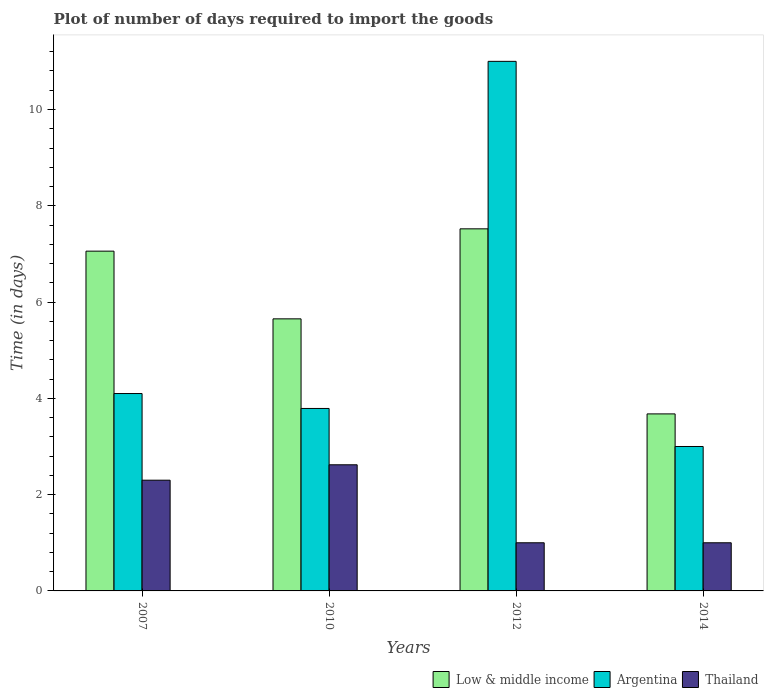How many different coloured bars are there?
Make the answer very short. 3. How many groups of bars are there?
Offer a terse response. 4. Are the number of bars per tick equal to the number of legend labels?
Give a very brief answer. Yes. How many bars are there on the 4th tick from the left?
Your response must be concise. 3. What is the label of the 4th group of bars from the left?
Offer a very short reply. 2014. In how many cases, is the number of bars for a given year not equal to the number of legend labels?
Make the answer very short. 0. What is the time required to import goods in Low & middle income in 2007?
Provide a short and direct response. 7.06. Across all years, what is the maximum time required to import goods in Argentina?
Your answer should be compact. 11. Across all years, what is the minimum time required to import goods in Low & middle income?
Offer a terse response. 3.68. What is the total time required to import goods in Low & middle income in the graph?
Offer a terse response. 23.91. What is the difference between the time required to import goods in Argentina in 2010 and that in 2014?
Provide a short and direct response. 0.79. What is the difference between the time required to import goods in Argentina in 2014 and the time required to import goods in Thailand in 2012?
Your response must be concise. 2. What is the average time required to import goods in Low & middle income per year?
Offer a very short reply. 5.98. In the year 2010, what is the difference between the time required to import goods in Thailand and time required to import goods in Low & middle income?
Offer a terse response. -3.03. In how many years, is the time required to import goods in Thailand greater than 4.4 days?
Offer a very short reply. 0. What is the ratio of the time required to import goods in Low & middle income in 2007 to that in 2014?
Offer a very short reply. 1.92. Is the time required to import goods in Thailand in 2012 less than that in 2014?
Your response must be concise. No. What is the difference between the highest and the second highest time required to import goods in Thailand?
Offer a terse response. 0.32. What is the difference between the highest and the lowest time required to import goods in Thailand?
Make the answer very short. 1.62. Is the sum of the time required to import goods in Argentina in 2010 and 2014 greater than the maximum time required to import goods in Thailand across all years?
Your answer should be very brief. Yes. What does the 3rd bar from the left in 2014 represents?
Your answer should be very brief. Thailand. How many bars are there?
Offer a terse response. 12. Are all the bars in the graph horizontal?
Provide a short and direct response. No. What is the difference between two consecutive major ticks on the Y-axis?
Ensure brevity in your answer.  2. Does the graph contain grids?
Offer a terse response. No. How many legend labels are there?
Make the answer very short. 3. What is the title of the graph?
Provide a succinct answer. Plot of number of days required to import the goods. Does "Australia" appear as one of the legend labels in the graph?
Your answer should be compact. No. What is the label or title of the X-axis?
Ensure brevity in your answer.  Years. What is the label or title of the Y-axis?
Offer a terse response. Time (in days). What is the Time (in days) in Low & middle income in 2007?
Offer a terse response. 7.06. What is the Time (in days) of Argentina in 2007?
Your answer should be compact. 4.1. What is the Time (in days) of Thailand in 2007?
Make the answer very short. 2.3. What is the Time (in days) in Low & middle income in 2010?
Ensure brevity in your answer.  5.65. What is the Time (in days) in Argentina in 2010?
Your response must be concise. 3.79. What is the Time (in days) in Thailand in 2010?
Provide a succinct answer. 2.62. What is the Time (in days) in Low & middle income in 2012?
Your answer should be compact. 7.52. What is the Time (in days) of Argentina in 2012?
Make the answer very short. 11. What is the Time (in days) of Thailand in 2012?
Offer a very short reply. 1. What is the Time (in days) in Low & middle income in 2014?
Offer a very short reply. 3.68. What is the Time (in days) in Argentina in 2014?
Make the answer very short. 3. What is the Time (in days) in Thailand in 2014?
Ensure brevity in your answer.  1. Across all years, what is the maximum Time (in days) of Low & middle income?
Your answer should be very brief. 7.52. Across all years, what is the maximum Time (in days) in Thailand?
Your answer should be very brief. 2.62. Across all years, what is the minimum Time (in days) of Low & middle income?
Offer a terse response. 3.68. Across all years, what is the minimum Time (in days) in Thailand?
Your answer should be compact. 1. What is the total Time (in days) in Low & middle income in the graph?
Your response must be concise. 23.91. What is the total Time (in days) of Argentina in the graph?
Ensure brevity in your answer.  21.89. What is the total Time (in days) in Thailand in the graph?
Give a very brief answer. 6.92. What is the difference between the Time (in days) in Low & middle income in 2007 and that in 2010?
Give a very brief answer. 1.41. What is the difference between the Time (in days) in Argentina in 2007 and that in 2010?
Provide a succinct answer. 0.31. What is the difference between the Time (in days) of Thailand in 2007 and that in 2010?
Ensure brevity in your answer.  -0.32. What is the difference between the Time (in days) in Low & middle income in 2007 and that in 2012?
Ensure brevity in your answer.  -0.46. What is the difference between the Time (in days) of Thailand in 2007 and that in 2012?
Your response must be concise. 1.3. What is the difference between the Time (in days) of Low & middle income in 2007 and that in 2014?
Provide a succinct answer. 3.38. What is the difference between the Time (in days) in Argentina in 2007 and that in 2014?
Ensure brevity in your answer.  1.1. What is the difference between the Time (in days) in Thailand in 2007 and that in 2014?
Your response must be concise. 1.3. What is the difference between the Time (in days) in Low & middle income in 2010 and that in 2012?
Ensure brevity in your answer.  -1.87. What is the difference between the Time (in days) in Argentina in 2010 and that in 2012?
Keep it short and to the point. -7.21. What is the difference between the Time (in days) of Thailand in 2010 and that in 2012?
Ensure brevity in your answer.  1.62. What is the difference between the Time (in days) of Low & middle income in 2010 and that in 2014?
Provide a succinct answer. 1.97. What is the difference between the Time (in days) of Argentina in 2010 and that in 2014?
Ensure brevity in your answer.  0.79. What is the difference between the Time (in days) of Thailand in 2010 and that in 2014?
Provide a succinct answer. 1.62. What is the difference between the Time (in days) in Low & middle income in 2012 and that in 2014?
Offer a terse response. 3.84. What is the difference between the Time (in days) of Low & middle income in 2007 and the Time (in days) of Argentina in 2010?
Offer a very short reply. 3.27. What is the difference between the Time (in days) of Low & middle income in 2007 and the Time (in days) of Thailand in 2010?
Make the answer very short. 4.44. What is the difference between the Time (in days) of Argentina in 2007 and the Time (in days) of Thailand in 2010?
Your response must be concise. 1.48. What is the difference between the Time (in days) of Low & middle income in 2007 and the Time (in days) of Argentina in 2012?
Offer a very short reply. -3.94. What is the difference between the Time (in days) of Low & middle income in 2007 and the Time (in days) of Thailand in 2012?
Your answer should be very brief. 6.06. What is the difference between the Time (in days) of Low & middle income in 2007 and the Time (in days) of Argentina in 2014?
Offer a terse response. 4.06. What is the difference between the Time (in days) of Low & middle income in 2007 and the Time (in days) of Thailand in 2014?
Offer a very short reply. 6.06. What is the difference between the Time (in days) of Low & middle income in 2010 and the Time (in days) of Argentina in 2012?
Keep it short and to the point. -5.35. What is the difference between the Time (in days) in Low & middle income in 2010 and the Time (in days) in Thailand in 2012?
Keep it short and to the point. 4.65. What is the difference between the Time (in days) in Argentina in 2010 and the Time (in days) in Thailand in 2012?
Give a very brief answer. 2.79. What is the difference between the Time (in days) of Low & middle income in 2010 and the Time (in days) of Argentina in 2014?
Your response must be concise. 2.65. What is the difference between the Time (in days) in Low & middle income in 2010 and the Time (in days) in Thailand in 2014?
Offer a very short reply. 4.65. What is the difference between the Time (in days) of Argentina in 2010 and the Time (in days) of Thailand in 2014?
Make the answer very short. 2.79. What is the difference between the Time (in days) of Low & middle income in 2012 and the Time (in days) of Argentina in 2014?
Give a very brief answer. 4.52. What is the difference between the Time (in days) of Low & middle income in 2012 and the Time (in days) of Thailand in 2014?
Your answer should be compact. 6.52. What is the average Time (in days) in Low & middle income per year?
Keep it short and to the point. 5.98. What is the average Time (in days) in Argentina per year?
Offer a very short reply. 5.47. What is the average Time (in days) in Thailand per year?
Make the answer very short. 1.73. In the year 2007, what is the difference between the Time (in days) of Low & middle income and Time (in days) of Argentina?
Ensure brevity in your answer.  2.96. In the year 2007, what is the difference between the Time (in days) of Low & middle income and Time (in days) of Thailand?
Make the answer very short. 4.76. In the year 2007, what is the difference between the Time (in days) of Argentina and Time (in days) of Thailand?
Offer a terse response. 1.8. In the year 2010, what is the difference between the Time (in days) in Low & middle income and Time (in days) in Argentina?
Provide a short and direct response. 1.86. In the year 2010, what is the difference between the Time (in days) in Low & middle income and Time (in days) in Thailand?
Give a very brief answer. 3.03. In the year 2010, what is the difference between the Time (in days) in Argentina and Time (in days) in Thailand?
Make the answer very short. 1.17. In the year 2012, what is the difference between the Time (in days) in Low & middle income and Time (in days) in Argentina?
Your response must be concise. -3.48. In the year 2012, what is the difference between the Time (in days) in Low & middle income and Time (in days) in Thailand?
Your answer should be compact. 6.52. In the year 2012, what is the difference between the Time (in days) in Argentina and Time (in days) in Thailand?
Give a very brief answer. 10. In the year 2014, what is the difference between the Time (in days) of Low & middle income and Time (in days) of Argentina?
Keep it short and to the point. 0.68. In the year 2014, what is the difference between the Time (in days) in Low & middle income and Time (in days) in Thailand?
Give a very brief answer. 2.68. In the year 2014, what is the difference between the Time (in days) in Argentina and Time (in days) in Thailand?
Provide a succinct answer. 2. What is the ratio of the Time (in days) of Low & middle income in 2007 to that in 2010?
Your answer should be compact. 1.25. What is the ratio of the Time (in days) of Argentina in 2007 to that in 2010?
Offer a terse response. 1.08. What is the ratio of the Time (in days) of Thailand in 2007 to that in 2010?
Offer a terse response. 0.88. What is the ratio of the Time (in days) of Low & middle income in 2007 to that in 2012?
Offer a very short reply. 0.94. What is the ratio of the Time (in days) in Argentina in 2007 to that in 2012?
Ensure brevity in your answer.  0.37. What is the ratio of the Time (in days) of Thailand in 2007 to that in 2012?
Provide a short and direct response. 2.3. What is the ratio of the Time (in days) of Low & middle income in 2007 to that in 2014?
Keep it short and to the point. 1.92. What is the ratio of the Time (in days) of Argentina in 2007 to that in 2014?
Give a very brief answer. 1.37. What is the ratio of the Time (in days) in Low & middle income in 2010 to that in 2012?
Your answer should be very brief. 0.75. What is the ratio of the Time (in days) in Argentina in 2010 to that in 2012?
Your answer should be compact. 0.34. What is the ratio of the Time (in days) of Thailand in 2010 to that in 2012?
Offer a terse response. 2.62. What is the ratio of the Time (in days) in Low & middle income in 2010 to that in 2014?
Offer a terse response. 1.54. What is the ratio of the Time (in days) of Argentina in 2010 to that in 2014?
Give a very brief answer. 1.26. What is the ratio of the Time (in days) of Thailand in 2010 to that in 2014?
Provide a succinct answer. 2.62. What is the ratio of the Time (in days) in Low & middle income in 2012 to that in 2014?
Ensure brevity in your answer.  2.05. What is the ratio of the Time (in days) in Argentina in 2012 to that in 2014?
Offer a very short reply. 3.67. What is the ratio of the Time (in days) of Thailand in 2012 to that in 2014?
Offer a very short reply. 1. What is the difference between the highest and the second highest Time (in days) in Low & middle income?
Offer a very short reply. 0.46. What is the difference between the highest and the second highest Time (in days) in Argentina?
Give a very brief answer. 6.9. What is the difference between the highest and the second highest Time (in days) in Thailand?
Offer a very short reply. 0.32. What is the difference between the highest and the lowest Time (in days) of Low & middle income?
Your answer should be very brief. 3.84. What is the difference between the highest and the lowest Time (in days) in Thailand?
Keep it short and to the point. 1.62. 